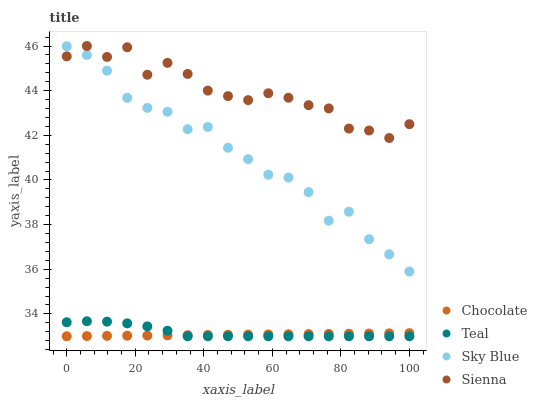Does Chocolate have the minimum area under the curve?
Answer yes or no. Yes. Does Sienna have the maximum area under the curve?
Answer yes or no. Yes. Does Sky Blue have the minimum area under the curve?
Answer yes or no. No. Does Sky Blue have the maximum area under the curve?
Answer yes or no. No. Is Chocolate the smoothest?
Answer yes or no. Yes. Is Sienna the roughest?
Answer yes or no. Yes. Is Sky Blue the smoothest?
Answer yes or no. No. Is Sky Blue the roughest?
Answer yes or no. No. Does Teal have the lowest value?
Answer yes or no. Yes. Does Sky Blue have the lowest value?
Answer yes or no. No. Does Sienna have the highest value?
Answer yes or no. Yes. Does Sky Blue have the highest value?
Answer yes or no. No. Is Teal less than Sienna?
Answer yes or no. Yes. Is Sky Blue greater than Teal?
Answer yes or no. Yes. Does Chocolate intersect Teal?
Answer yes or no. Yes. Is Chocolate less than Teal?
Answer yes or no. No. Is Chocolate greater than Teal?
Answer yes or no. No. Does Teal intersect Sienna?
Answer yes or no. No. 